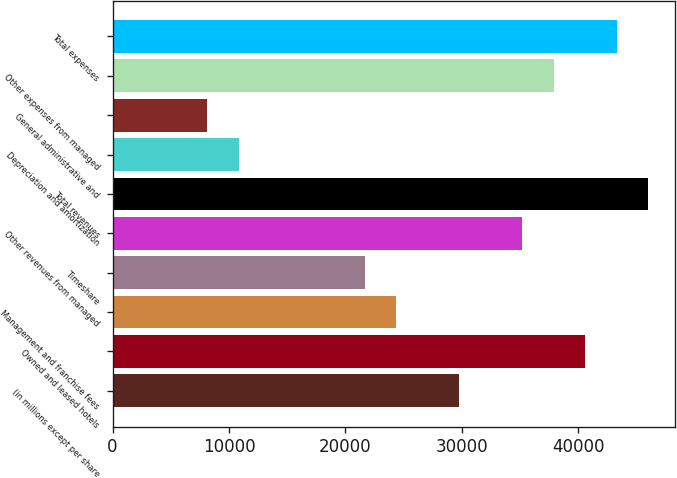Convert chart. <chart><loc_0><loc_0><loc_500><loc_500><bar_chart><fcel>(in millions except per share<fcel>Owned and leased hotels<fcel>Management and franchise fees<fcel>Timeshare<fcel>Other revenues from managed<fcel>Total revenues<fcel>Depreciation and amortization<fcel>General administrative and<fcel>Other expenses from managed<fcel>Total expenses<nl><fcel>29772.5<fcel>40598.8<fcel>24359.4<fcel>21652.9<fcel>35185.7<fcel>46011.9<fcel>10826.6<fcel>8120.06<fcel>37892.2<fcel>43305.3<nl></chart> 